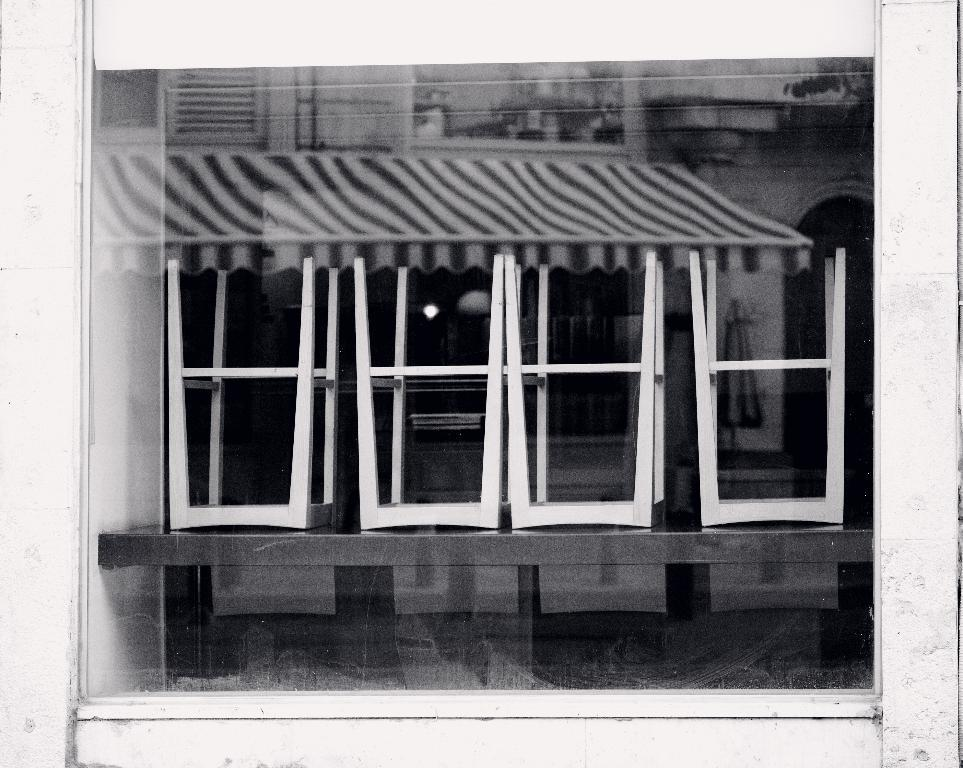What is the main subject in the center of the image? There is a window in the center of the image. What can be seen in the window's reflection? The window has reflections of a table, chairs, a wall, and a tent. Can you describe the different elements visible in the window's reflection? The window's reflection shows a table, chairs, a wall, and a tent. What type of shirt is the goat wearing in the image? There is no goat or shirt present in the image; it features a window with reflections of various objects. What is the plot of the story unfolding in the image? The image does not depict a story or plot; it is a photograph of a window with reflections. 